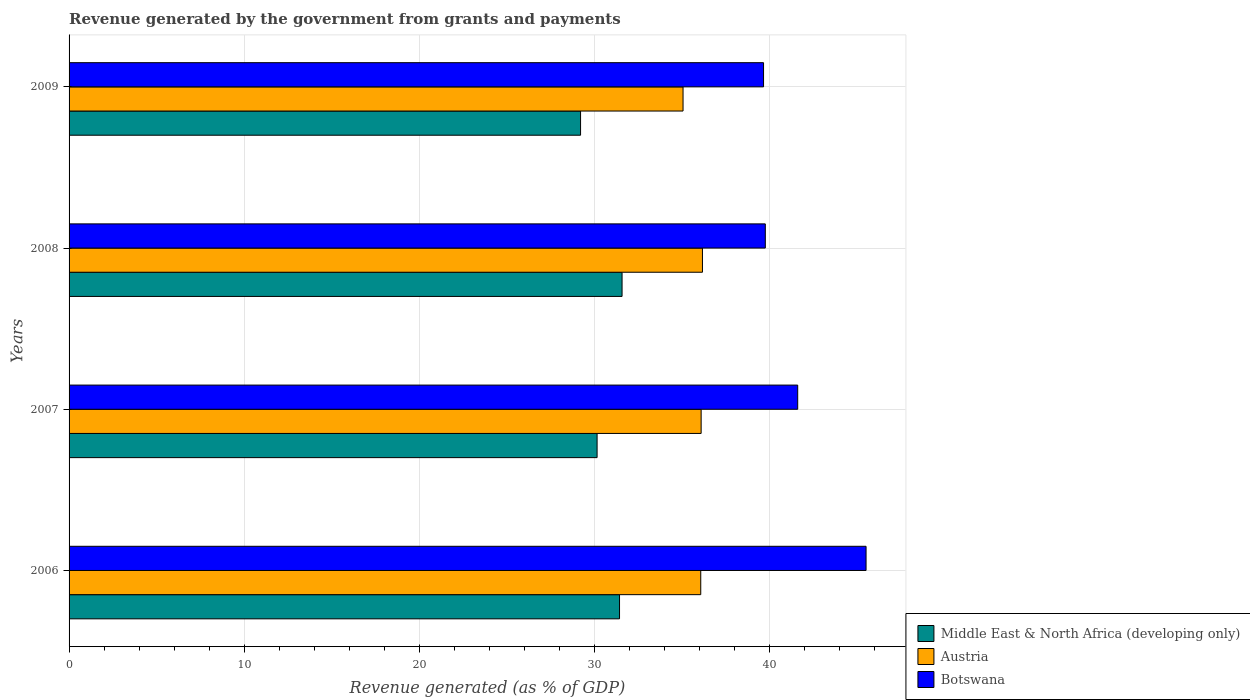How many different coloured bars are there?
Give a very brief answer. 3. Are the number of bars on each tick of the Y-axis equal?
Provide a succinct answer. Yes. How many bars are there on the 2nd tick from the bottom?
Ensure brevity in your answer.  3. What is the label of the 3rd group of bars from the top?
Your answer should be very brief. 2007. In how many cases, is the number of bars for a given year not equal to the number of legend labels?
Your response must be concise. 0. What is the revenue generated by the government in Middle East & North Africa (developing only) in 2008?
Your answer should be very brief. 31.6. Across all years, what is the maximum revenue generated by the government in Middle East & North Africa (developing only)?
Offer a terse response. 31.6. Across all years, what is the minimum revenue generated by the government in Botswana?
Give a very brief answer. 39.68. What is the total revenue generated by the government in Austria in the graph?
Ensure brevity in your answer.  143.48. What is the difference between the revenue generated by the government in Middle East & North Africa (developing only) in 2006 and that in 2007?
Your answer should be very brief. 1.28. What is the difference between the revenue generated by the government in Middle East & North Africa (developing only) in 2009 and the revenue generated by the government in Botswana in 2008?
Your response must be concise. -10.56. What is the average revenue generated by the government in Botswana per year?
Provide a short and direct response. 41.66. In the year 2008, what is the difference between the revenue generated by the government in Middle East & North Africa (developing only) and revenue generated by the government in Botswana?
Ensure brevity in your answer.  -8.18. In how many years, is the revenue generated by the government in Botswana greater than 14 %?
Offer a terse response. 4. What is the ratio of the revenue generated by the government in Middle East & North Africa (developing only) in 2006 to that in 2007?
Give a very brief answer. 1.04. Is the revenue generated by the government in Austria in 2008 less than that in 2009?
Your response must be concise. No. What is the difference between the highest and the second highest revenue generated by the government in Middle East & North Africa (developing only)?
Ensure brevity in your answer.  0.14. What is the difference between the highest and the lowest revenue generated by the government in Middle East & North Africa (developing only)?
Ensure brevity in your answer.  2.37. What does the 1st bar from the top in 2006 represents?
Your answer should be compact. Botswana. Is it the case that in every year, the sum of the revenue generated by the government in Austria and revenue generated by the government in Botswana is greater than the revenue generated by the government in Middle East & North Africa (developing only)?
Offer a very short reply. Yes. How many bars are there?
Keep it short and to the point. 12. Are all the bars in the graph horizontal?
Provide a succinct answer. Yes. What is the title of the graph?
Provide a short and direct response. Revenue generated by the government from grants and payments. What is the label or title of the X-axis?
Give a very brief answer. Revenue generated (as % of GDP). What is the label or title of the Y-axis?
Your answer should be very brief. Years. What is the Revenue generated (as % of GDP) of Middle East & North Africa (developing only) in 2006?
Make the answer very short. 31.45. What is the Revenue generated (as % of GDP) of Austria in 2006?
Keep it short and to the point. 36.09. What is the Revenue generated (as % of GDP) of Botswana in 2006?
Your answer should be very brief. 45.54. What is the Revenue generated (as % of GDP) of Middle East & North Africa (developing only) in 2007?
Your response must be concise. 30.17. What is the Revenue generated (as % of GDP) of Austria in 2007?
Give a very brief answer. 36.11. What is the Revenue generated (as % of GDP) of Botswana in 2007?
Keep it short and to the point. 41.63. What is the Revenue generated (as % of GDP) of Middle East & North Africa (developing only) in 2008?
Offer a very short reply. 31.6. What is the Revenue generated (as % of GDP) of Austria in 2008?
Make the answer very short. 36.19. What is the Revenue generated (as % of GDP) of Botswana in 2008?
Ensure brevity in your answer.  39.78. What is the Revenue generated (as % of GDP) in Middle East & North Africa (developing only) in 2009?
Provide a succinct answer. 29.23. What is the Revenue generated (as % of GDP) in Austria in 2009?
Your response must be concise. 35.08. What is the Revenue generated (as % of GDP) in Botswana in 2009?
Ensure brevity in your answer.  39.68. Across all years, what is the maximum Revenue generated (as % of GDP) in Middle East & North Africa (developing only)?
Provide a succinct answer. 31.6. Across all years, what is the maximum Revenue generated (as % of GDP) in Austria?
Keep it short and to the point. 36.19. Across all years, what is the maximum Revenue generated (as % of GDP) in Botswana?
Give a very brief answer. 45.54. Across all years, what is the minimum Revenue generated (as % of GDP) of Middle East & North Africa (developing only)?
Your answer should be compact. 29.23. Across all years, what is the minimum Revenue generated (as % of GDP) in Austria?
Give a very brief answer. 35.08. Across all years, what is the minimum Revenue generated (as % of GDP) of Botswana?
Offer a very short reply. 39.68. What is the total Revenue generated (as % of GDP) of Middle East & North Africa (developing only) in the graph?
Ensure brevity in your answer.  122.44. What is the total Revenue generated (as % of GDP) of Austria in the graph?
Your response must be concise. 143.48. What is the total Revenue generated (as % of GDP) in Botswana in the graph?
Offer a terse response. 166.63. What is the difference between the Revenue generated (as % of GDP) in Middle East & North Africa (developing only) in 2006 and that in 2007?
Ensure brevity in your answer.  1.28. What is the difference between the Revenue generated (as % of GDP) in Austria in 2006 and that in 2007?
Keep it short and to the point. -0.02. What is the difference between the Revenue generated (as % of GDP) of Botswana in 2006 and that in 2007?
Give a very brief answer. 3.91. What is the difference between the Revenue generated (as % of GDP) of Middle East & North Africa (developing only) in 2006 and that in 2008?
Offer a terse response. -0.14. What is the difference between the Revenue generated (as % of GDP) of Austria in 2006 and that in 2008?
Make the answer very short. -0.1. What is the difference between the Revenue generated (as % of GDP) in Botswana in 2006 and that in 2008?
Your response must be concise. 5.76. What is the difference between the Revenue generated (as % of GDP) in Middle East & North Africa (developing only) in 2006 and that in 2009?
Ensure brevity in your answer.  2.23. What is the difference between the Revenue generated (as % of GDP) in Austria in 2006 and that in 2009?
Provide a short and direct response. 1.01. What is the difference between the Revenue generated (as % of GDP) in Botswana in 2006 and that in 2009?
Make the answer very short. 5.86. What is the difference between the Revenue generated (as % of GDP) of Middle East & North Africa (developing only) in 2007 and that in 2008?
Ensure brevity in your answer.  -1.43. What is the difference between the Revenue generated (as % of GDP) in Austria in 2007 and that in 2008?
Offer a terse response. -0.07. What is the difference between the Revenue generated (as % of GDP) in Botswana in 2007 and that in 2008?
Provide a short and direct response. 1.85. What is the difference between the Revenue generated (as % of GDP) in Middle East & North Africa (developing only) in 2007 and that in 2009?
Offer a very short reply. 0.94. What is the difference between the Revenue generated (as % of GDP) in Austria in 2007 and that in 2009?
Offer a very short reply. 1.03. What is the difference between the Revenue generated (as % of GDP) of Botswana in 2007 and that in 2009?
Ensure brevity in your answer.  1.95. What is the difference between the Revenue generated (as % of GDP) in Middle East & North Africa (developing only) in 2008 and that in 2009?
Keep it short and to the point. 2.37. What is the difference between the Revenue generated (as % of GDP) of Austria in 2008 and that in 2009?
Provide a succinct answer. 1.11. What is the difference between the Revenue generated (as % of GDP) in Botswana in 2008 and that in 2009?
Give a very brief answer. 0.1. What is the difference between the Revenue generated (as % of GDP) in Middle East & North Africa (developing only) in 2006 and the Revenue generated (as % of GDP) in Austria in 2007?
Provide a short and direct response. -4.66. What is the difference between the Revenue generated (as % of GDP) in Middle East & North Africa (developing only) in 2006 and the Revenue generated (as % of GDP) in Botswana in 2007?
Your response must be concise. -10.18. What is the difference between the Revenue generated (as % of GDP) of Austria in 2006 and the Revenue generated (as % of GDP) of Botswana in 2007?
Make the answer very short. -5.54. What is the difference between the Revenue generated (as % of GDP) in Middle East & North Africa (developing only) in 2006 and the Revenue generated (as % of GDP) in Austria in 2008?
Give a very brief answer. -4.74. What is the difference between the Revenue generated (as % of GDP) in Middle East & North Africa (developing only) in 2006 and the Revenue generated (as % of GDP) in Botswana in 2008?
Give a very brief answer. -8.33. What is the difference between the Revenue generated (as % of GDP) in Austria in 2006 and the Revenue generated (as % of GDP) in Botswana in 2008?
Your answer should be very brief. -3.69. What is the difference between the Revenue generated (as % of GDP) of Middle East & North Africa (developing only) in 2006 and the Revenue generated (as % of GDP) of Austria in 2009?
Provide a succinct answer. -3.63. What is the difference between the Revenue generated (as % of GDP) in Middle East & North Africa (developing only) in 2006 and the Revenue generated (as % of GDP) in Botswana in 2009?
Your answer should be compact. -8.23. What is the difference between the Revenue generated (as % of GDP) in Austria in 2006 and the Revenue generated (as % of GDP) in Botswana in 2009?
Give a very brief answer. -3.59. What is the difference between the Revenue generated (as % of GDP) of Middle East & North Africa (developing only) in 2007 and the Revenue generated (as % of GDP) of Austria in 2008?
Ensure brevity in your answer.  -6.02. What is the difference between the Revenue generated (as % of GDP) of Middle East & North Africa (developing only) in 2007 and the Revenue generated (as % of GDP) of Botswana in 2008?
Your answer should be very brief. -9.61. What is the difference between the Revenue generated (as % of GDP) of Austria in 2007 and the Revenue generated (as % of GDP) of Botswana in 2008?
Offer a very short reply. -3.67. What is the difference between the Revenue generated (as % of GDP) of Middle East & North Africa (developing only) in 2007 and the Revenue generated (as % of GDP) of Austria in 2009?
Make the answer very short. -4.91. What is the difference between the Revenue generated (as % of GDP) of Middle East & North Africa (developing only) in 2007 and the Revenue generated (as % of GDP) of Botswana in 2009?
Offer a terse response. -9.51. What is the difference between the Revenue generated (as % of GDP) in Austria in 2007 and the Revenue generated (as % of GDP) in Botswana in 2009?
Provide a succinct answer. -3.57. What is the difference between the Revenue generated (as % of GDP) of Middle East & North Africa (developing only) in 2008 and the Revenue generated (as % of GDP) of Austria in 2009?
Your answer should be compact. -3.48. What is the difference between the Revenue generated (as % of GDP) in Middle East & North Africa (developing only) in 2008 and the Revenue generated (as % of GDP) in Botswana in 2009?
Your answer should be very brief. -8.08. What is the difference between the Revenue generated (as % of GDP) in Austria in 2008 and the Revenue generated (as % of GDP) in Botswana in 2009?
Give a very brief answer. -3.49. What is the average Revenue generated (as % of GDP) of Middle East & North Africa (developing only) per year?
Keep it short and to the point. 30.61. What is the average Revenue generated (as % of GDP) of Austria per year?
Your answer should be very brief. 35.87. What is the average Revenue generated (as % of GDP) in Botswana per year?
Keep it short and to the point. 41.66. In the year 2006, what is the difference between the Revenue generated (as % of GDP) in Middle East & North Africa (developing only) and Revenue generated (as % of GDP) in Austria?
Give a very brief answer. -4.64. In the year 2006, what is the difference between the Revenue generated (as % of GDP) in Middle East & North Africa (developing only) and Revenue generated (as % of GDP) in Botswana?
Make the answer very short. -14.09. In the year 2006, what is the difference between the Revenue generated (as % of GDP) in Austria and Revenue generated (as % of GDP) in Botswana?
Give a very brief answer. -9.45. In the year 2007, what is the difference between the Revenue generated (as % of GDP) of Middle East & North Africa (developing only) and Revenue generated (as % of GDP) of Austria?
Keep it short and to the point. -5.95. In the year 2007, what is the difference between the Revenue generated (as % of GDP) of Middle East & North Africa (developing only) and Revenue generated (as % of GDP) of Botswana?
Keep it short and to the point. -11.46. In the year 2007, what is the difference between the Revenue generated (as % of GDP) in Austria and Revenue generated (as % of GDP) in Botswana?
Provide a succinct answer. -5.52. In the year 2008, what is the difference between the Revenue generated (as % of GDP) of Middle East & North Africa (developing only) and Revenue generated (as % of GDP) of Austria?
Keep it short and to the point. -4.59. In the year 2008, what is the difference between the Revenue generated (as % of GDP) in Middle East & North Africa (developing only) and Revenue generated (as % of GDP) in Botswana?
Your answer should be compact. -8.18. In the year 2008, what is the difference between the Revenue generated (as % of GDP) of Austria and Revenue generated (as % of GDP) of Botswana?
Your response must be concise. -3.59. In the year 2009, what is the difference between the Revenue generated (as % of GDP) in Middle East & North Africa (developing only) and Revenue generated (as % of GDP) in Austria?
Keep it short and to the point. -5.86. In the year 2009, what is the difference between the Revenue generated (as % of GDP) in Middle East & North Africa (developing only) and Revenue generated (as % of GDP) in Botswana?
Ensure brevity in your answer.  -10.46. In the year 2009, what is the difference between the Revenue generated (as % of GDP) of Austria and Revenue generated (as % of GDP) of Botswana?
Make the answer very short. -4.6. What is the ratio of the Revenue generated (as % of GDP) of Middle East & North Africa (developing only) in 2006 to that in 2007?
Give a very brief answer. 1.04. What is the ratio of the Revenue generated (as % of GDP) of Austria in 2006 to that in 2007?
Your answer should be compact. 1. What is the ratio of the Revenue generated (as % of GDP) in Botswana in 2006 to that in 2007?
Offer a very short reply. 1.09. What is the ratio of the Revenue generated (as % of GDP) of Middle East & North Africa (developing only) in 2006 to that in 2008?
Provide a short and direct response. 1. What is the ratio of the Revenue generated (as % of GDP) in Austria in 2006 to that in 2008?
Provide a succinct answer. 1. What is the ratio of the Revenue generated (as % of GDP) of Botswana in 2006 to that in 2008?
Provide a succinct answer. 1.14. What is the ratio of the Revenue generated (as % of GDP) in Middle East & North Africa (developing only) in 2006 to that in 2009?
Offer a terse response. 1.08. What is the ratio of the Revenue generated (as % of GDP) of Austria in 2006 to that in 2009?
Make the answer very short. 1.03. What is the ratio of the Revenue generated (as % of GDP) of Botswana in 2006 to that in 2009?
Make the answer very short. 1.15. What is the ratio of the Revenue generated (as % of GDP) in Middle East & North Africa (developing only) in 2007 to that in 2008?
Offer a terse response. 0.95. What is the ratio of the Revenue generated (as % of GDP) of Austria in 2007 to that in 2008?
Ensure brevity in your answer.  1. What is the ratio of the Revenue generated (as % of GDP) in Botswana in 2007 to that in 2008?
Provide a short and direct response. 1.05. What is the ratio of the Revenue generated (as % of GDP) in Middle East & North Africa (developing only) in 2007 to that in 2009?
Your response must be concise. 1.03. What is the ratio of the Revenue generated (as % of GDP) of Austria in 2007 to that in 2009?
Your answer should be very brief. 1.03. What is the ratio of the Revenue generated (as % of GDP) of Botswana in 2007 to that in 2009?
Provide a short and direct response. 1.05. What is the ratio of the Revenue generated (as % of GDP) of Middle East & North Africa (developing only) in 2008 to that in 2009?
Offer a very short reply. 1.08. What is the ratio of the Revenue generated (as % of GDP) in Austria in 2008 to that in 2009?
Provide a succinct answer. 1.03. What is the ratio of the Revenue generated (as % of GDP) in Botswana in 2008 to that in 2009?
Provide a short and direct response. 1. What is the difference between the highest and the second highest Revenue generated (as % of GDP) of Middle East & North Africa (developing only)?
Ensure brevity in your answer.  0.14. What is the difference between the highest and the second highest Revenue generated (as % of GDP) of Austria?
Provide a succinct answer. 0.07. What is the difference between the highest and the second highest Revenue generated (as % of GDP) in Botswana?
Your response must be concise. 3.91. What is the difference between the highest and the lowest Revenue generated (as % of GDP) of Middle East & North Africa (developing only)?
Offer a terse response. 2.37. What is the difference between the highest and the lowest Revenue generated (as % of GDP) of Austria?
Make the answer very short. 1.11. What is the difference between the highest and the lowest Revenue generated (as % of GDP) in Botswana?
Provide a short and direct response. 5.86. 